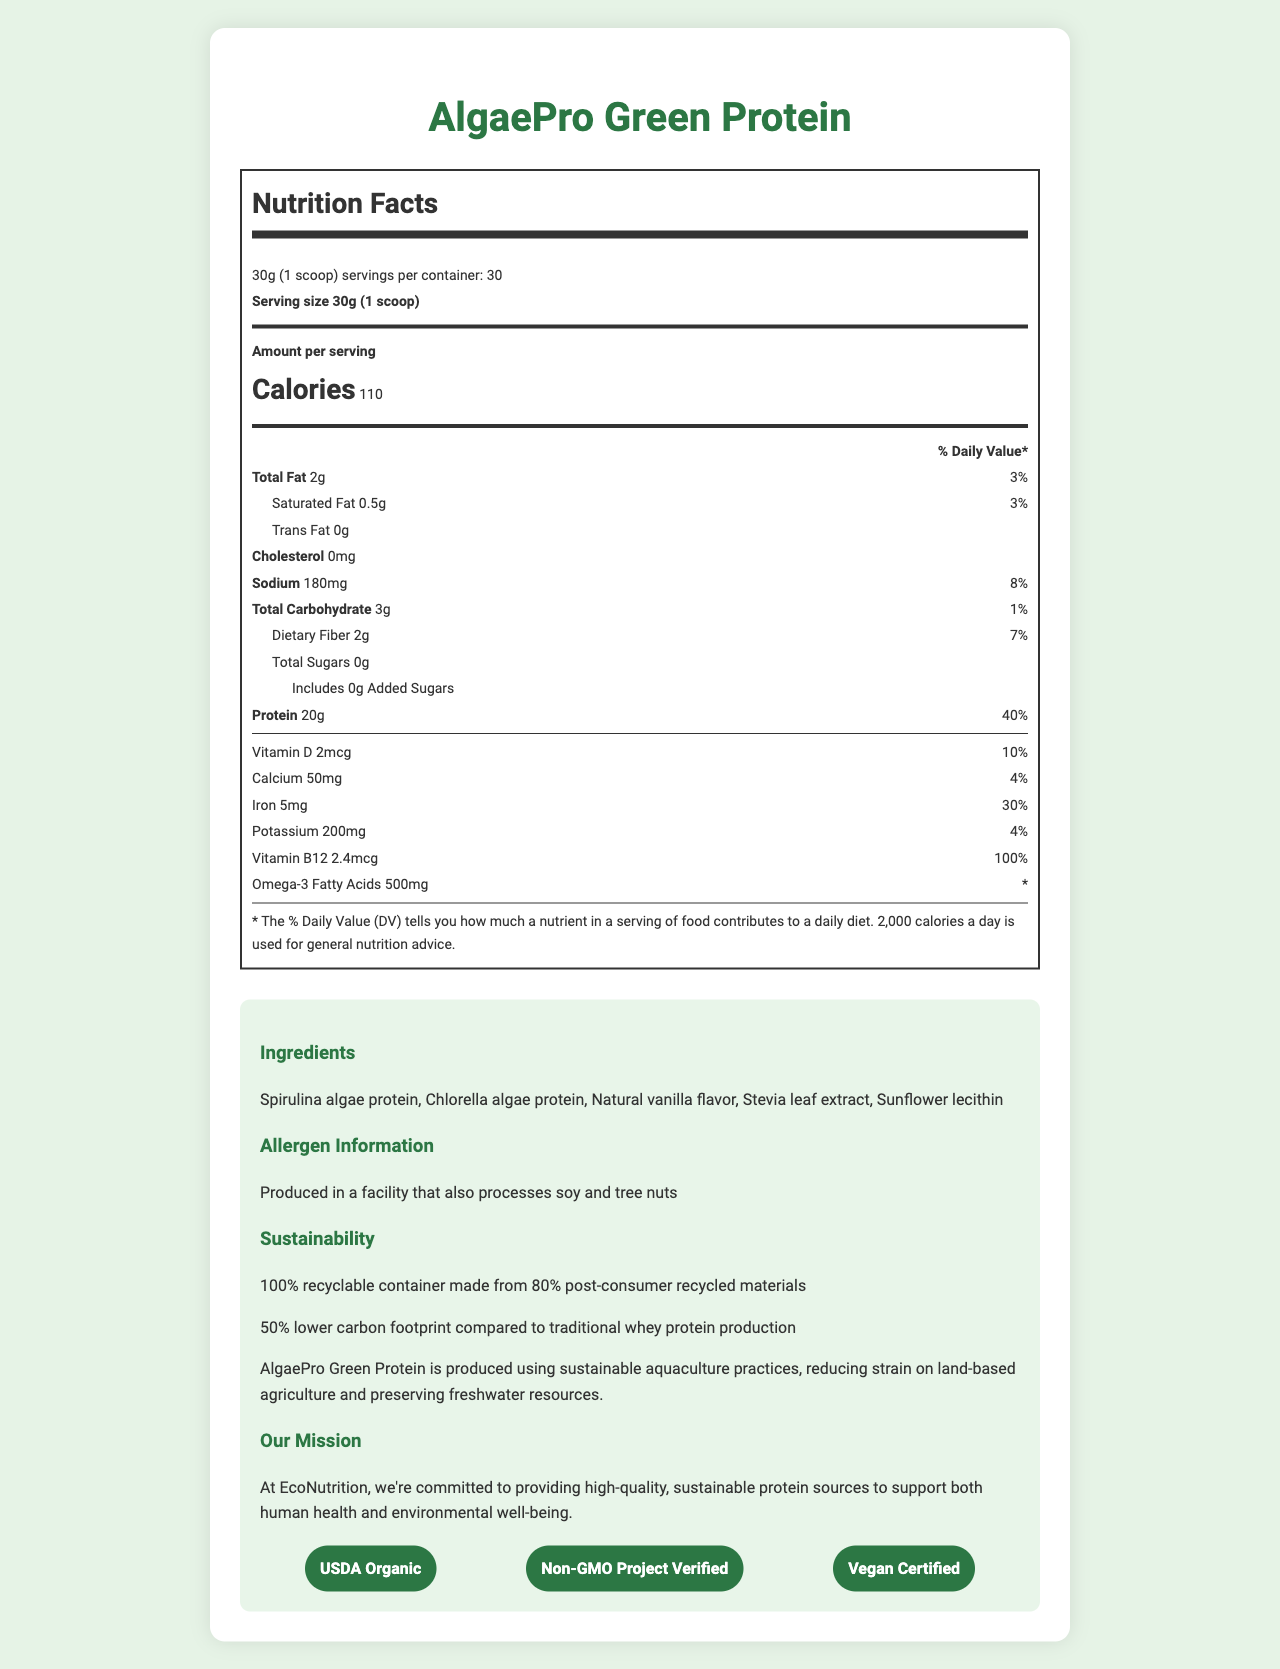what is the serving size for AlgaePro Green Protein? The serving size is explicitly mentioned as “30g (1 scoop)” in the nutrition facts label.
Answer: 30g (1 scoop) how many calories are in one serving of AlgaePro Green Protein? The document states that there are 110 calories per serving.
Answer: 110 what is the total fat content per serving and its daily value percentage? The total fat content per serving is listed as 2g, which is 3% of the daily value.
Answer: 2g, 3% what is the amount of dietary fiber per serving? The dietary fiber content per serving is stated to be 2g.
Answer: 2g how much Vitamin B12 does one serving provide, and what is its daily value percentage? The Vitamin B12 content is 2.4mcg per serving, with a daily value percentage of 100%.
Answer: 2.4mcg, 100% which certifications does AlgaePro Green Protein have? A. Gluten-Free B. USDA Organic C. Non-GMO Project Verified D. Vegan Certified The document lists “USDA Organic,” “Non-GMO Project Verified,” and “Vegan Certified” among the product's certifications.
Answer: B, C, D what is the daily value percentage of Iron in one serving of AlgaePro Green Protein? A. 10% B. 20% C. 30% D. 50% According to the nutrition facts, the daily value percentage of Iron is 30%.
Answer: C. 30% does AlgaePro Green Protein contain any cholesterol? The document states that there is "0mg" of cholesterol in the product.
Answer: No is the AlgaePro Green Protein packaging eco-friendly? The document mentions that the packaging is “100% recyclable container made from 80% post-consumer recycled materials.”
Answer: Yes what is the main idea of the document? The main idea revolves around presenting the comprehensive nutrition facts, ingredients, allergen information, sustainability aspects, and the mission of EcoNutrition for their product, AlgaePro Green Protein.
Answer: The document provides detailed nutritional information, sustainability features, and the company's mission for the AlgaePro Green Protein, a plant-based protein powder made from algae biomass, emphasizing its eco-friendly and health-conscious benefits. how is AlgaePro Green Protein produced? The document describes the nutritional and sustainability features but does not specify the production process in detail.
Answer: Cannot be determined what are the ingredients in AlgaePro Green Protein? The ingredients list is clearly enumerated in the document.
Answer: Spirulina algae protein, Chlorella algae protein, Natural vanilla flavor, Stevia leaf extract, Sunflower lecithin what is the protein content per serving and its daily value percentage? AlgaePro Green Protein provides 20g of protein per serving, which is 40% of the daily value.
Answer: 20g, 40% what is the amount of Omega-3 fatty acids in one serving? The Omega-3 fatty acids content per serving is listed as 500mg.
Answer: 500mg what kind of allergen information is provided for AlgaePro Green Protein? The document includes an allergen statement indicating potential cross-contamination with soy and tree nuts.
Answer: Produced in a facility that also processes soy and tree nuts 